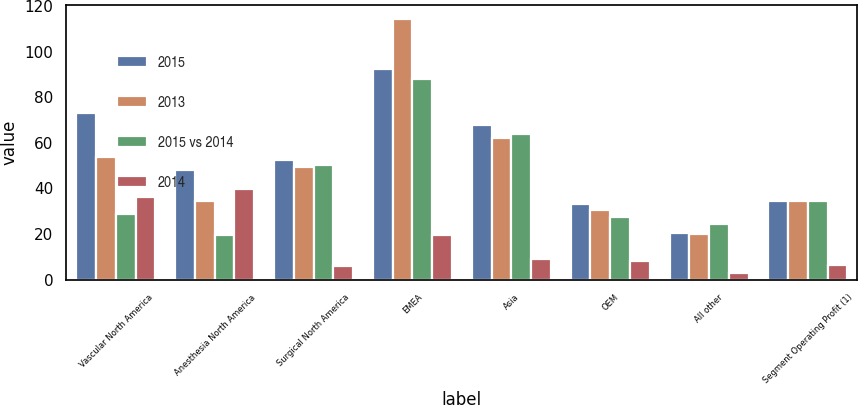Convert chart to OTSL. <chart><loc_0><loc_0><loc_500><loc_500><stacked_bar_chart><ecel><fcel>Vascular North America<fcel>Anesthesia North America<fcel>Surgical North America<fcel>EMEA<fcel>Asia<fcel>OEM<fcel>All other<fcel>Segment Operating Profit (1)<nl><fcel>2015<fcel>73.3<fcel>48.3<fcel>52.5<fcel>92.3<fcel>67.9<fcel>33.2<fcel>20.4<fcel>34.6<nl><fcel>2013<fcel>53.8<fcel>34.6<fcel>49.6<fcel>114.6<fcel>62.2<fcel>30.6<fcel>19.8<fcel>34.6<nl><fcel>2015 vs 2014<fcel>28.8<fcel>19.5<fcel>50.4<fcel>87.9<fcel>63.8<fcel>27.3<fcel>24.6<fcel>34.6<nl><fcel>2014<fcel>36.2<fcel>39.8<fcel>5.9<fcel>19.5<fcel>9.2<fcel>8.2<fcel>3<fcel>6.2<nl></chart> 